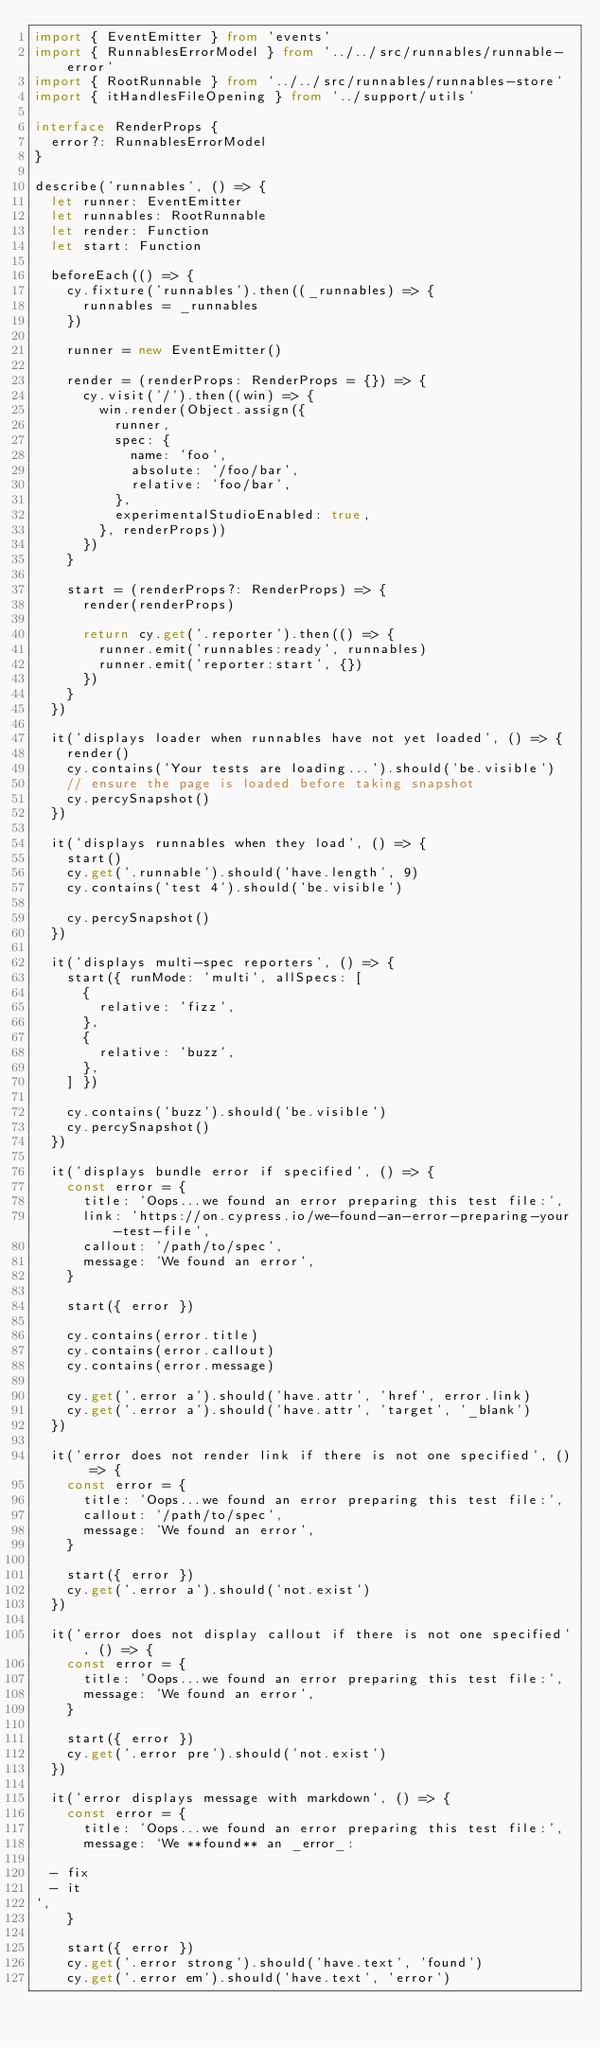Convert code to text. <code><loc_0><loc_0><loc_500><loc_500><_TypeScript_>import { EventEmitter } from 'events'
import { RunnablesErrorModel } from '../../src/runnables/runnable-error'
import { RootRunnable } from '../../src/runnables/runnables-store'
import { itHandlesFileOpening } from '../support/utils'

interface RenderProps {
  error?: RunnablesErrorModel
}

describe('runnables', () => {
  let runner: EventEmitter
  let runnables: RootRunnable
  let render: Function
  let start: Function

  beforeEach(() => {
    cy.fixture('runnables').then((_runnables) => {
      runnables = _runnables
    })

    runner = new EventEmitter()

    render = (renderProps: RenderProps = {}) => {
      cy.visit('/').then((win) => {
        win.render(Object.assign({
          runner,
          spec: {
            name: 'foo',
            absolute: '/foo/bar',
            relative: 'foo/bar',
          },
          experimentalStudioEnabled: true,
        }, renderProps))
      })
    }

    start = (renderProps?: RenderProps) => {
      render(renderProps)

      return cy.get('.reporter').then(() => {
        runner.emit('runnables:ready', runnables)
        runner.emit('reporter:start', {})
      })
    }
  })

  it('displays loader when runnables have not yet loaded', () => {
    render()
    cy.contains('Your tests are loading...').should('be.visible')
    // ensure the page is loaded before taking snapshot
    cy.percySnapshot()
  })

  it('displays runnables when they load', () => {
    start()
    cy.get('.runnable').should('have.length', 9)
    cy.contains('test 4').should('be.visible')

    cy.percySnapshot()
  })

  it('displays multi-spec reporters', () => {
    start({ runMode: 'multi', allSpecs: [
      {
        relative: 'fizz',
      },
      {
        relative: 'buzz',
      },
    ] })

    cy.contains('buzz').should('be.visible')
    cy.percySnapshot()
  })

  it('displays bundle error if specified', () => {
    const error = {
      title: 'Oops...we found an error preparing this test file:',
      link: 'https://on.cypress.io/we-found-an-error-preparing-your-test-file',
      callout: '/path/to/spec',
      message: 'We found an error',
    }

    start({ error })

    cy.contains(error.title)
    cy.contains(error.callout)
    cy.contains(error.message)

    cy.get('.error a').should('have.attr', 'href', error.link)
    cy.get('.error a').should('have.attr', 'target', '_blank')
  })

  it('error does not render link if there is not one specified', () => {
    const error = {
      title: 'Oops...we found an error preparing this test file:',
      callout: '/path/to/spec',
      message: 'We found an error',
    }

    start({ error })
    cy.get('.error a').should('not.exist')
  })

  it('error does not display callout if there is not one specified', () => {
    const error = {
      title: 'Oops...we found an error preparing this test file:',
      message: 'We found an error',
    }

    start({ error })
    cy.get('.error pre').should('not.exist')
  })

  it('error displays message with markdown', () => {
    const error = {
      title: 'Oops...we found an error preparing this test file:',
      message: `We **found** an _error_:

  - fix
  - it
`,
    }

    start({ error })
    cy.get('.error strong').should('have.text', 'found')
    cy.get('.error em').should('have.text', 'error')</code> 